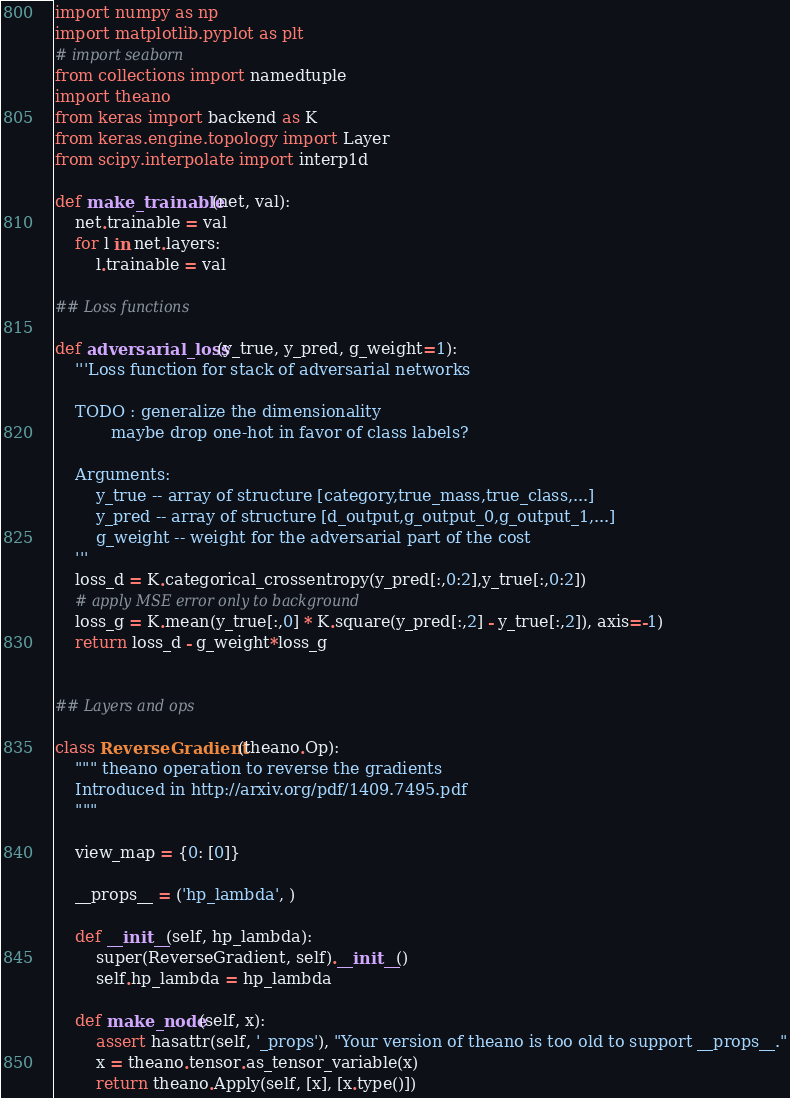<code> <loc_0><loc_0><loc_500><loc_500><_Python_>import numpy as np 
import matplotlib.pyplot as plt 
# import seaborn 
from collections import namedtuple
import theano 
from keras import backend as K
from keras.engine.topology import Layer
from scipy.interpolate import interp1d

def make_trainable(net, val):
    net.trainable = val
    for l in net.layers:
        l.trainable = val

## Loss functions 

def adversarial_loss(y_true, y_pred, g_weight=1):
    '''Loss function for stack of adversarial networks
    
    TODO : generalize the dimensionality 
           maybe drop one-hot in favor of class labels?

    Arguments:
        y_true -- array of structure [category,true_mass,true_class,...]
        y_pred -- array of structure [d_output,g_output_0,g_output_1,...]
        g_weight -- weight for the adversarial part of the cost 
    '''
    loss_d = K.categorical_crossentropy(y_pred[:,0:2],y_true[:,0:2])
    # apply MSE error only to background 
    loss_g = K.mean(y_true[:,0] * K.square(y_pred[:,2] - y_true[:,2]), axis=-1) 
    return loss_d - g_weight*loss_g 


## Layers and ops 

class ReverseGradient(theano.Op):
    """ theano operation to reverse the gradients
    Introduced in http://arxiv.org/pdf/1409.7495.pdf
    """

    view_map = {0: [0]}

    __props__ = ('hp_lambda', )

    def __init__(self, hp_lambda):
        super(ReverseGradient, self).__init__()
        self.hp_lambda = hp_lambda

    def make_node(self, x):
        assert hasattr(self, '_props'), "Your version of theano is too old to support __props__."
        x = theano.tensor.as_tensor_variable(x)
        return theano.Apply(self, [x], [x.type()])
</code> 